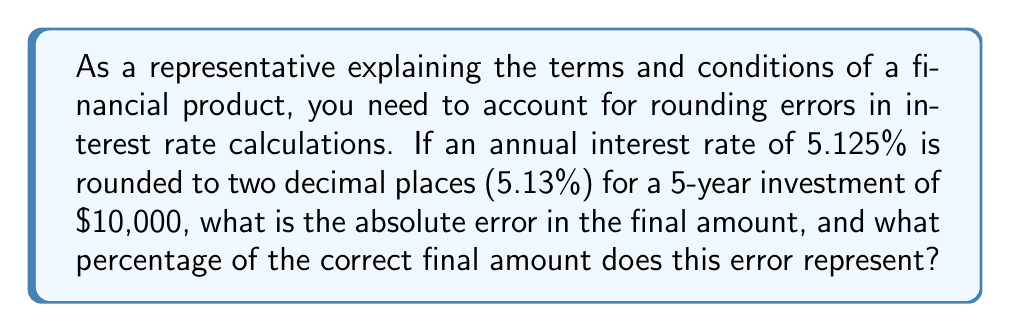Give your solution to this math problem. Let's approach this step-by-step:

1) First, let's calculate the correct final amount after 5 years:
   $$A_1 = P(1 + r)^n = 10000(1 + 0.05125)^5 = 12836.84$$

2) Now, let's calculate the final amount using the rounded interest rate:
   $$A_2 = P(1 + r)^n = 10000(1 + 0.0513)^5 = 12839.85$$

3) The absolute error is the difference between these two values:
   $$\text{Absolute Error} = |A_2 - A_1| = |12839.85 - 12836.84| = 3.01$$

4) To calculate the percentage error, we divide the absolute error by the correct value and multiply by 100:
   $$\text{Percentage Error} = \frac{\text{Absolute Error}}{A_1} \times 100\% = \frac{3.01}{12836.84} \times 100\% = 0.0234\%$$

This error propagation occurs due to the compounding effect over the 5-year period. Even a small rounding in the interest rate can lead to a noticeable difference in the final amount, especially for larger principal amounts or longer time periods.
Answer: The absolute error is $3.01, and it represents 0.0234% of the correct final amount. 